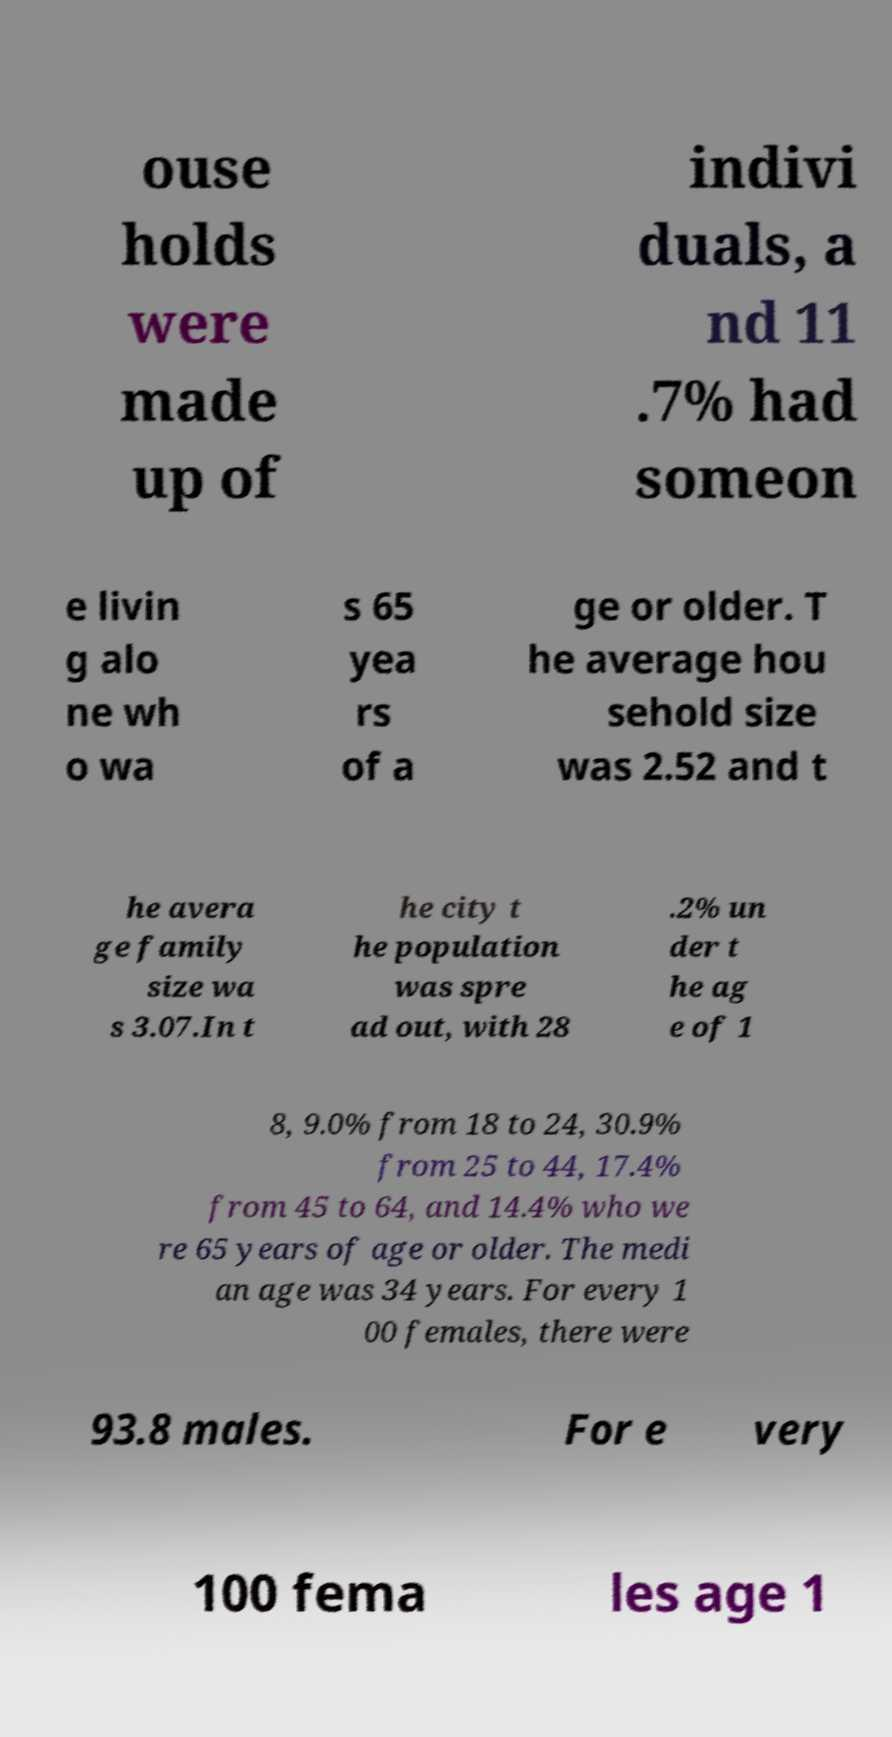For documentation purposes, I need the text within this image transcribed. Could you provide that? ouse holds were made up of indivi duals, a nd 11 .7% had someon e livin g alo ne wh o wa s 65 yea rs of a ge or older. T he average hou sehold size was 2.52 and t he avera ge family size wa s 3.07.In t he city t he population was spre ad out, with 28 .2% un der t he ag e of 1 8, 9.0% from 18 to 24, 30.9% from 25 to 44, 17.4% from 45 to 64, and 14.4% who we re 65 years of age or older. The medi an age was 34 years. For every 1 00 females, there were 93.8 males. For e very 100 fema les age 1 